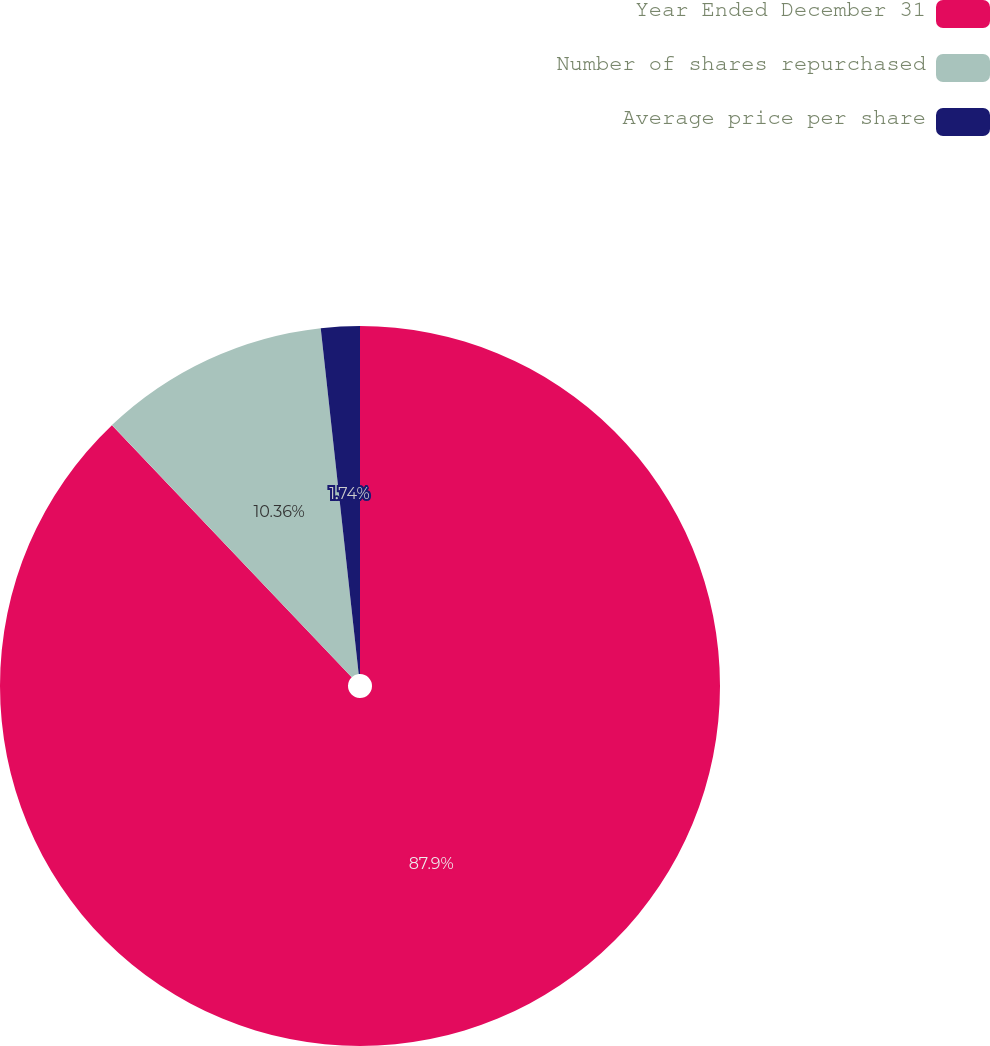Convert chart. <chart><loc_0><loc_0><loc_500><loc_500><pie_chart><fcel>Year Ended December 31<fcel>Number of shares repurchased<fcel>Average price per share<nl><fcel>87.9%<fcel>10.36%<fcel>1.74%<nl></chart> 